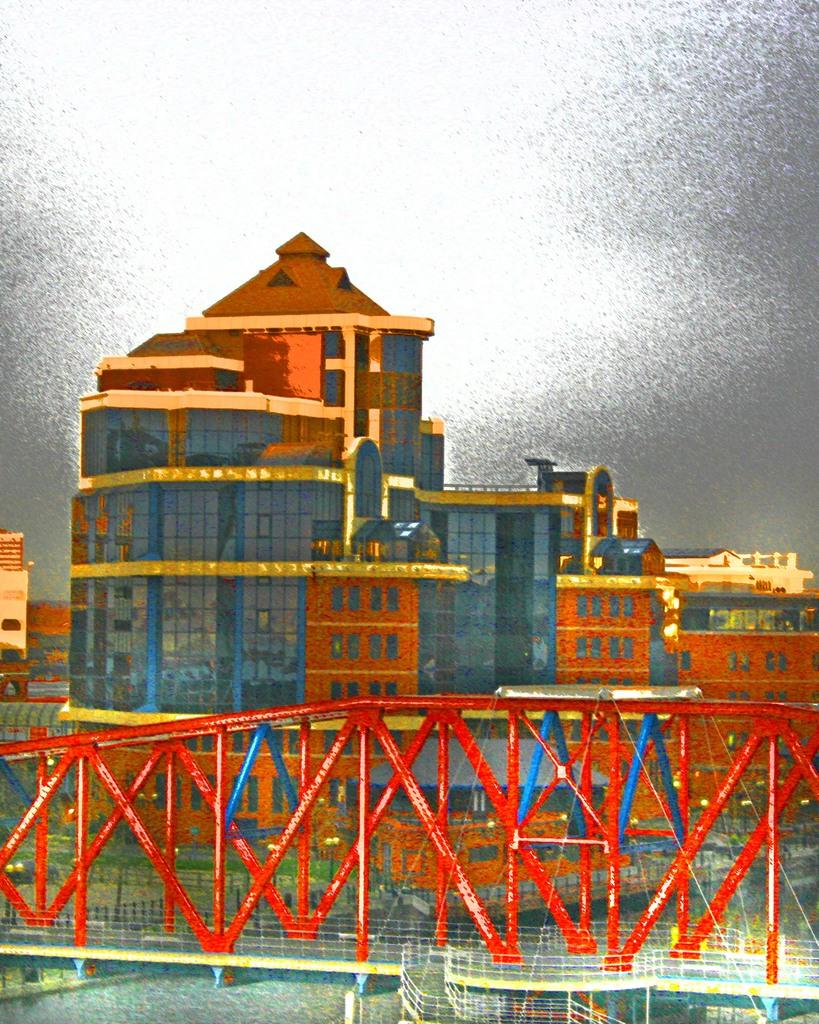What type of image is being described? The image is graphical in nature. What is the goose doing in the tub in the image? There is no goose or tub present in the image, as it is described as being graphical in nature. 